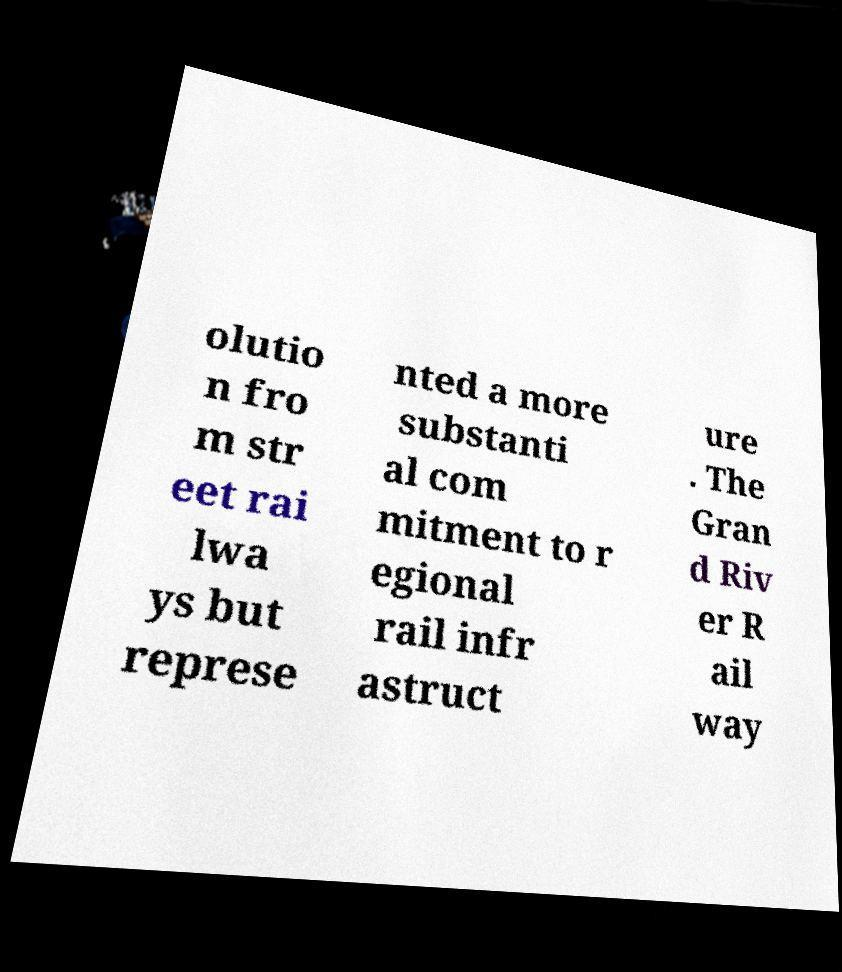Please read and relay the text visible in this image. What does it say? olutio n fro m str eet rai lwa ys but represe nted a more substanti al com mitment to r egional rail infr astruct ure . The Gran d Riv er R ail way 